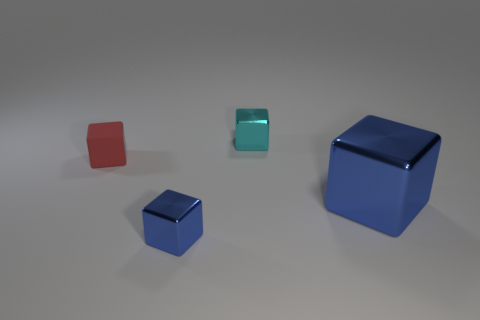Subtract 1 cubes. How many cubes are left? 3 Add 2 tiny things. How many objects exist? 6 Add 3 cubes. How many cubes are left? 7 Add 2 tiny cyan things. How many tiny cyan things exist? 3 Subtract 0 green cylinders. How many objects are left? 4 Subtract all tiny green rubber spheres. Subtract all small cyan metallic blocks. How many objects are left? 3 